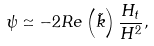<formula> <loc_0><loc_0><loc_500><loc_500>\psi \simeq - 2 R e \left ( \tilde { k } \right ) \frac { H _ { t } } { H ^ { 2 } } ,</formula> 